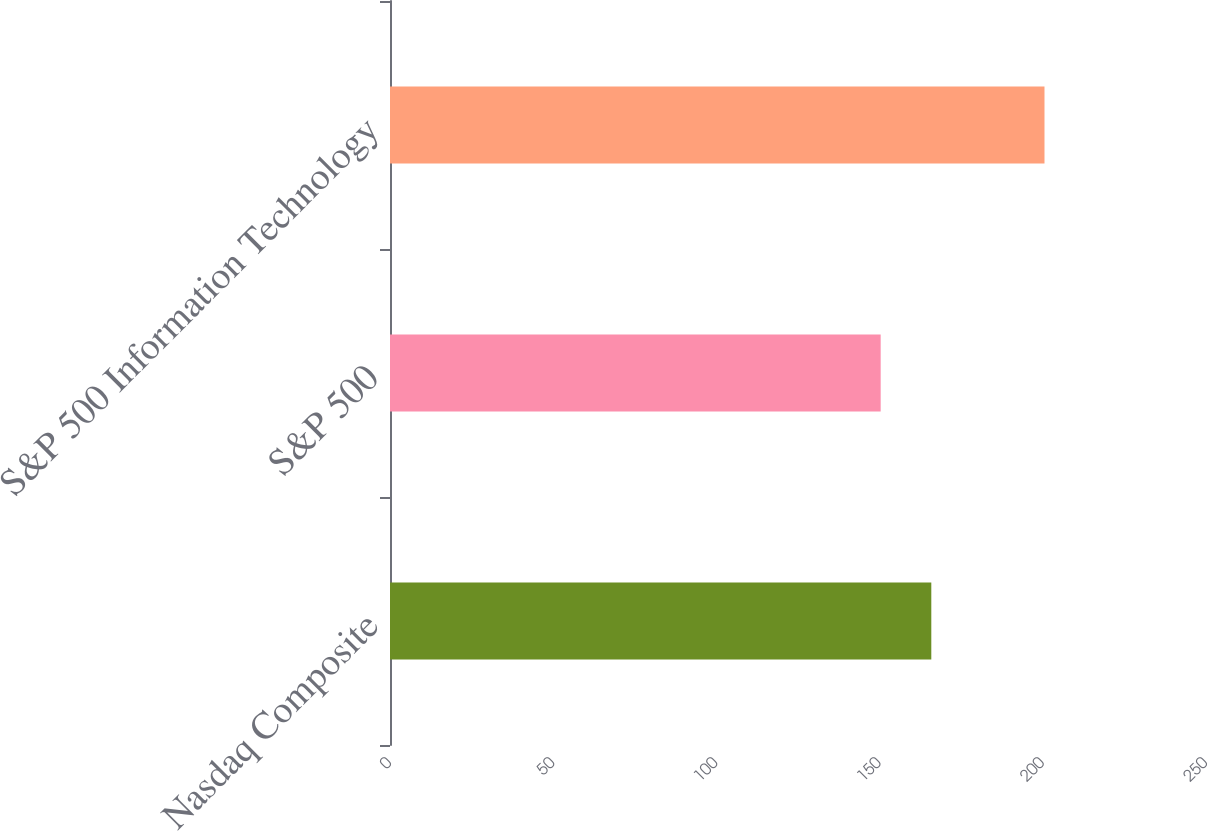Convert chart. <chart><loc_0><loc_0><loc_500><loc_500><bar_chart><fcel>Nasdaq Composite<fcel>S&P 500<fcel>S&P 500 Information Technology<nl><fcel>165.84<fcel>150.33<fcel>200.52<nl></chart> 